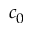Convert formula to latex. <formula><loc_0><loc_0><loc_500><loc_500>c _ { 0 }</formula> 